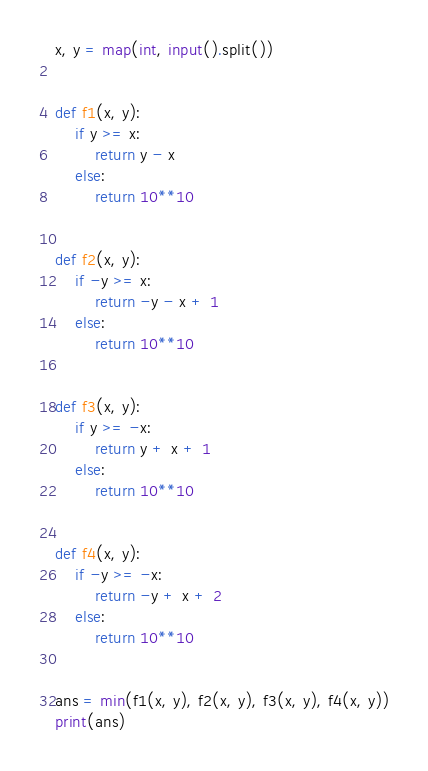Convert code to text. <code><loc_0><loc_0><loc_500><loc_500><_Python_>x, y = map(int, input().split())


def f1(x, y):
    if y >= x:
        return y - x
    else:
        return 10**10


def f2(x, y):
    if -y >= x:
        return -y - x + 1
    else:
        return 10**10


def f3(x, y):
    if y >= -x:
        return y + x + 1
    else:
        return 10**10


def f4(x, y):
    if -y >= -x:
        return -y + x + 2
    else:
        return 10**10


ans = min(f1(x, y), f2(x, y), f3(x, y), f4(x, y))
print(ans)
</code> 